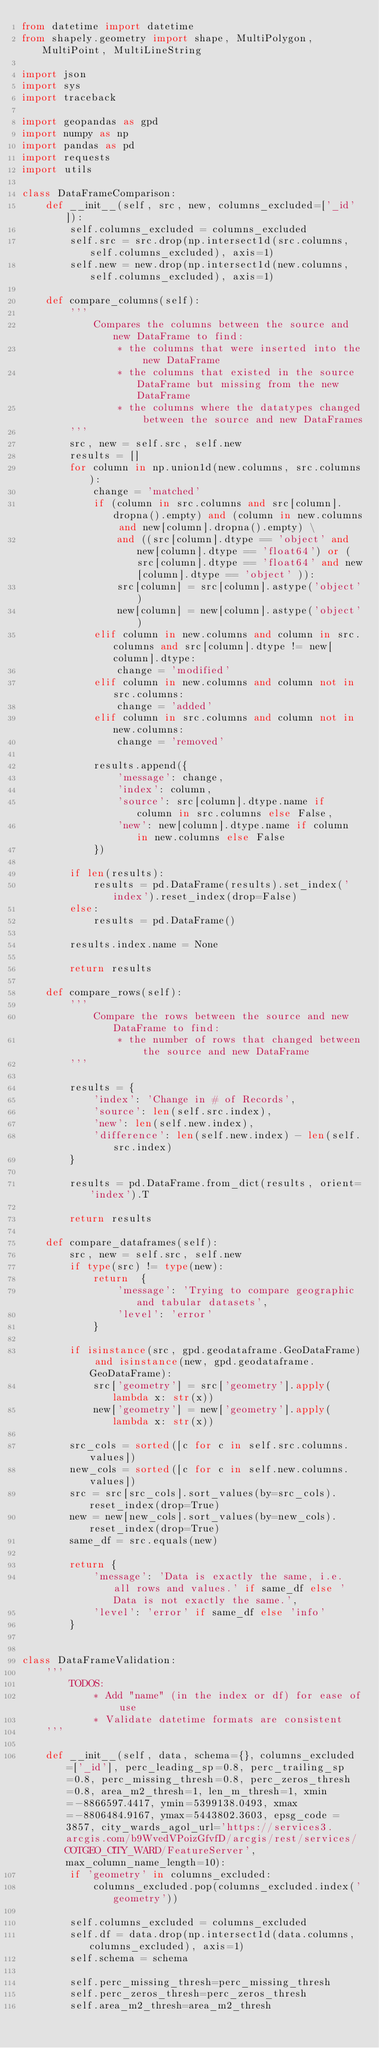<code> <loc_0><loc_0><loc_500><loc_500><_Python_>from datetime import datetime
from shapely.geometry import shape, MultiPolygon, MultiPoint, MultiLineString

import json
import sys
import traceback

import geopandas as gpd
import numpy as np
import pandas as pd
import requests
import utils

class DataFrameComparison:
    def __init__(self, src, new, columns_excluded=['_id']):
        self.columns_excluded = columns_excluded
        self.src = src.drop(np.intersect1d(src.columns, self.columns_excluded), axis=1)
        self.new = new.drop(np.intersect1d(new.columns, self.columns_excluded), axis=1)

    def compare_columns(self):
        '''
            Compares the columns between the source and new DataFrame to find:
                * the columns that were inserted into the new DataFrame
                * the columns that existed in the source DataFrame but missing from the new DataFrame
                * the columns where the datatypes changed between the source and new DataFrames
        '''
        src, new = self.src, self.new
        results = []
        for column in np.union1d(new.columns, src.columns):
            change = 'matched'
            if (column in src.columns and src[column].dropna().empty) and (column in new.columns and new[column].dropna().empty) \
                and ((src[column].dtype == 'object' and new[column].dtype == 'float64') or ( src[column].dtype == 'float64' and new[column].dtype == 'object' )):
                src[column] = src[column].astype('object')
                new[column] = new[column].astype('object')
            elif column in new.columns and column in src.columns and src[column].dtype != new[column].dtype:
                change = 'modified'
            elif column in new.columns and column not in src.columns:
                change = 'added'
            elif column in src.columns and column not in new.columns:
                change = 'removed'

            results.append({
                'message': change,
                'index': column,
                'source': src[column].dtype.name if column in src.columns else False,
                'new': new[column].dtype.name if column in new.columns else False
            })

        if len(results):
            results = pd.DataFrame(results).set_index('index').reset_index(drop=False) 
        else:
            results = pd.DataFrame()
        
        results.index.name = None

        return results

    def compare_rows(self):
        '''
            Compare the rows between the source and new DataFrame to find:
                * the number of rows that changed between the source and new DataFrame
        '''

        results = {
            'index': 'Change in # of Records',
            'source': len(self.src.index),
            'new': len(self.new.index),
            'difference': len(self.new.index) - len(self.src.index)
        }

        results = pd.DataFrame.from_dict(results, orient='index').T

        return results

    def compare_dataframes(self):
        src, new = self.src, self.new
        if type(src) != type(new):
            return  {
                'message': 'Trying to compare geographic and tabular datasets',
                'level': 'error'
            }

        if isinstance(src, gpd.geodataframe.GeoDataFrame) and isinstance(new, gpd.geodataframe.GeoDataFrame):
            src['geometry'] = src['geometry'].apply(lambda x: str(x))
            new['geometry'] = new['geometry'].apply(lambda x: str(x))

        src_cols = sorted([c for c in self.src.columns.values])
        new_cols = sorted([c for c in self.new.columns.values])
        src = src[src_cols].sort_values(by=src_cols).reset_index(drop=True)
        new = new[new_cols].sort_values(by=new_cols).reset_index(drop=True)
        same_df = src.equals(new)

        return {
            'message': 'Data is exactly the same, i.e. all rows and values.' if same_df else 'Data is not exactly the same.',
            'level': 'error' if same_df else 'info'
        }
        

class DataFrameValidation:
    '''
        TODOS:
            * Add "name" (in the index or df) for ease of use
            * Validate datetime formats are consistent
    '''

    def __init__(self, data, schema={}, columns_excluded=['_id'], perc_leading_sp=0.8, perc_trailing_sp=0.8, perc_missing_thresh=0.8, perc_zeros_thresh=0.8, area_m2_thresh=1, len_m_thresh=1, xmin=-8866597.4417, ymin=5399138.0493, xmax=-8806484.9167, ymax=5443802.3603, epsg_code = 3857, city_wards_agol_url='https://services3.arcgis.com/b9WvedVPoizGfvfD/arcgis/rest/services/COTGEO_CITY_WARD/FeatureServer', max_column_name_length=10):
        if 'geometry' in columns_excluded:
            columns_excluded.pop(columns_excluded.index('geometry'))

        self.columns_excluded = columns_excluded
        self.df = data.drop(np.intersect1d(data.columns, columns_excluded), axis=1)
        self.schema = schema

        self.perc_missing_thresh=perc_missing_thresh
        self.perc_zeros_thresh=perc_zeros_thresh
        self.area_m2_thresh=area_m2_thresh</code> 